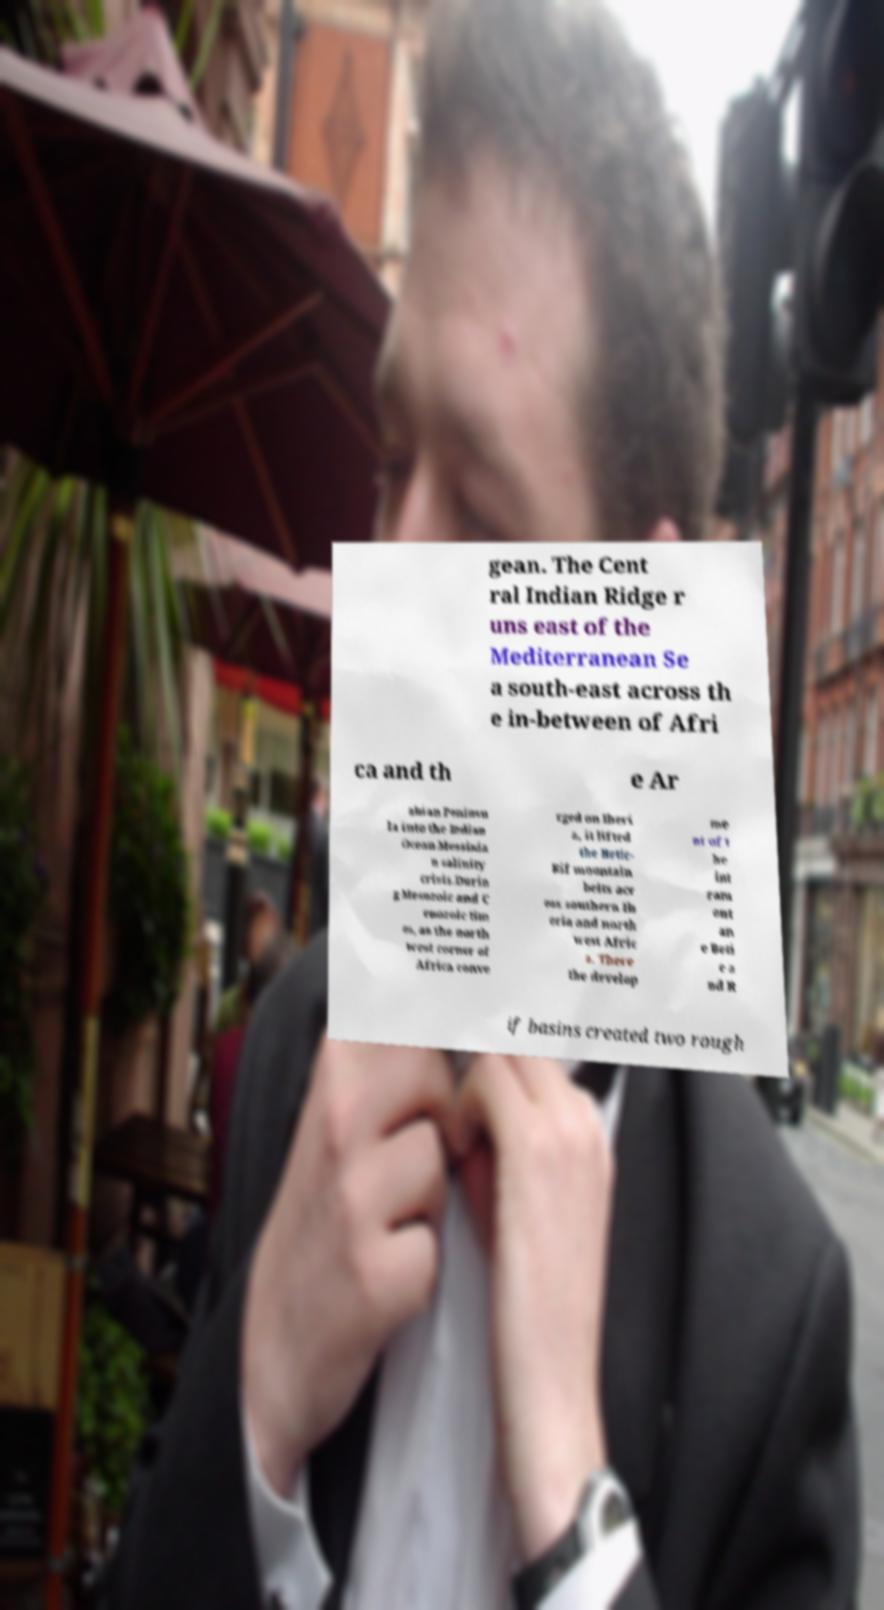What messages or text are displayed in this image? I need them in a readable, typed format. gean. The Cent ral Indian Ridge r uns east of the Mediterranean Se a south-east across th e in-between of Afri ca and th e Ar abian Peninsu la into the Indian Ocean.Messinia n salinity crisis.Durin g Mesozoic and C enozoic tim es, as the north west corner of Africa conve rged on Iberi a, it lifted the Betic- Rif mountain belts acr oss southern Ib eria and north west Afric a. There the develop me nt of t he int ram ont an e Beti c a nd R if basins created two rough 